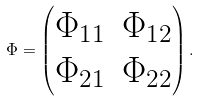<formula> <loc_0><loc_0><loc_500><loc_500>\Phi = \left ( \begin{matrix} \Phi _ { 1 1 } & \Phi _ { 1 2 } \\ \Phi _ { 2 1 } & \Phi _ { 2 2 } \end{matrix} \right ) .</formula> 